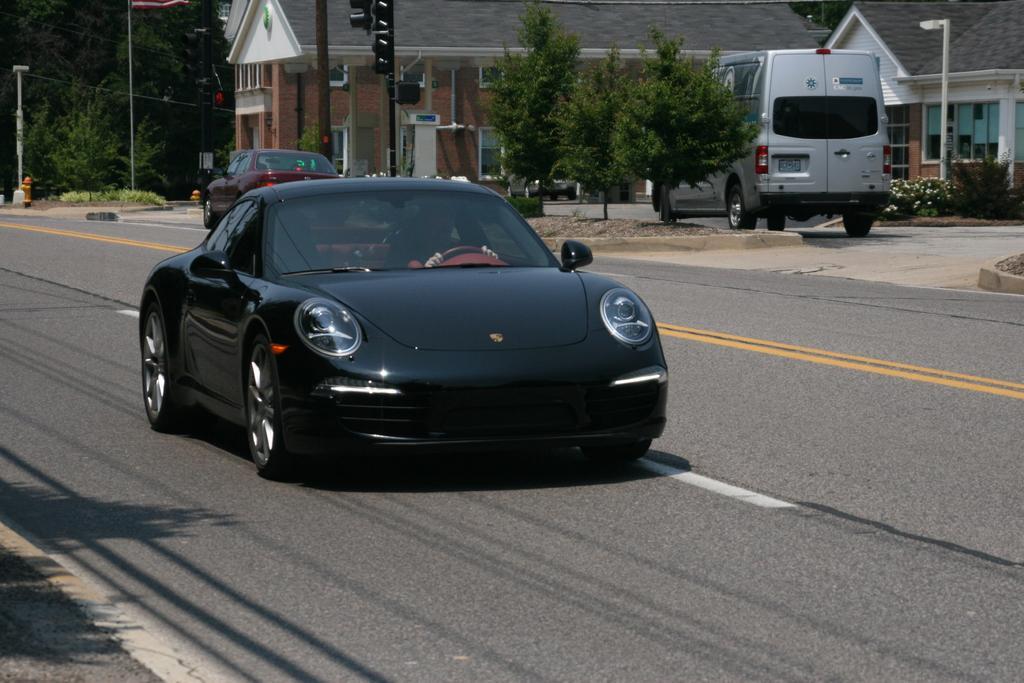Can you describe this image briefly? In this image I can see the road. On the road I can see many vehicles. To the side of the road I can see the poles and many trees. In the background I can see house. In-front of the house I can see the white color flowers to the plants. I can also see the vehicle in-front of the house. 